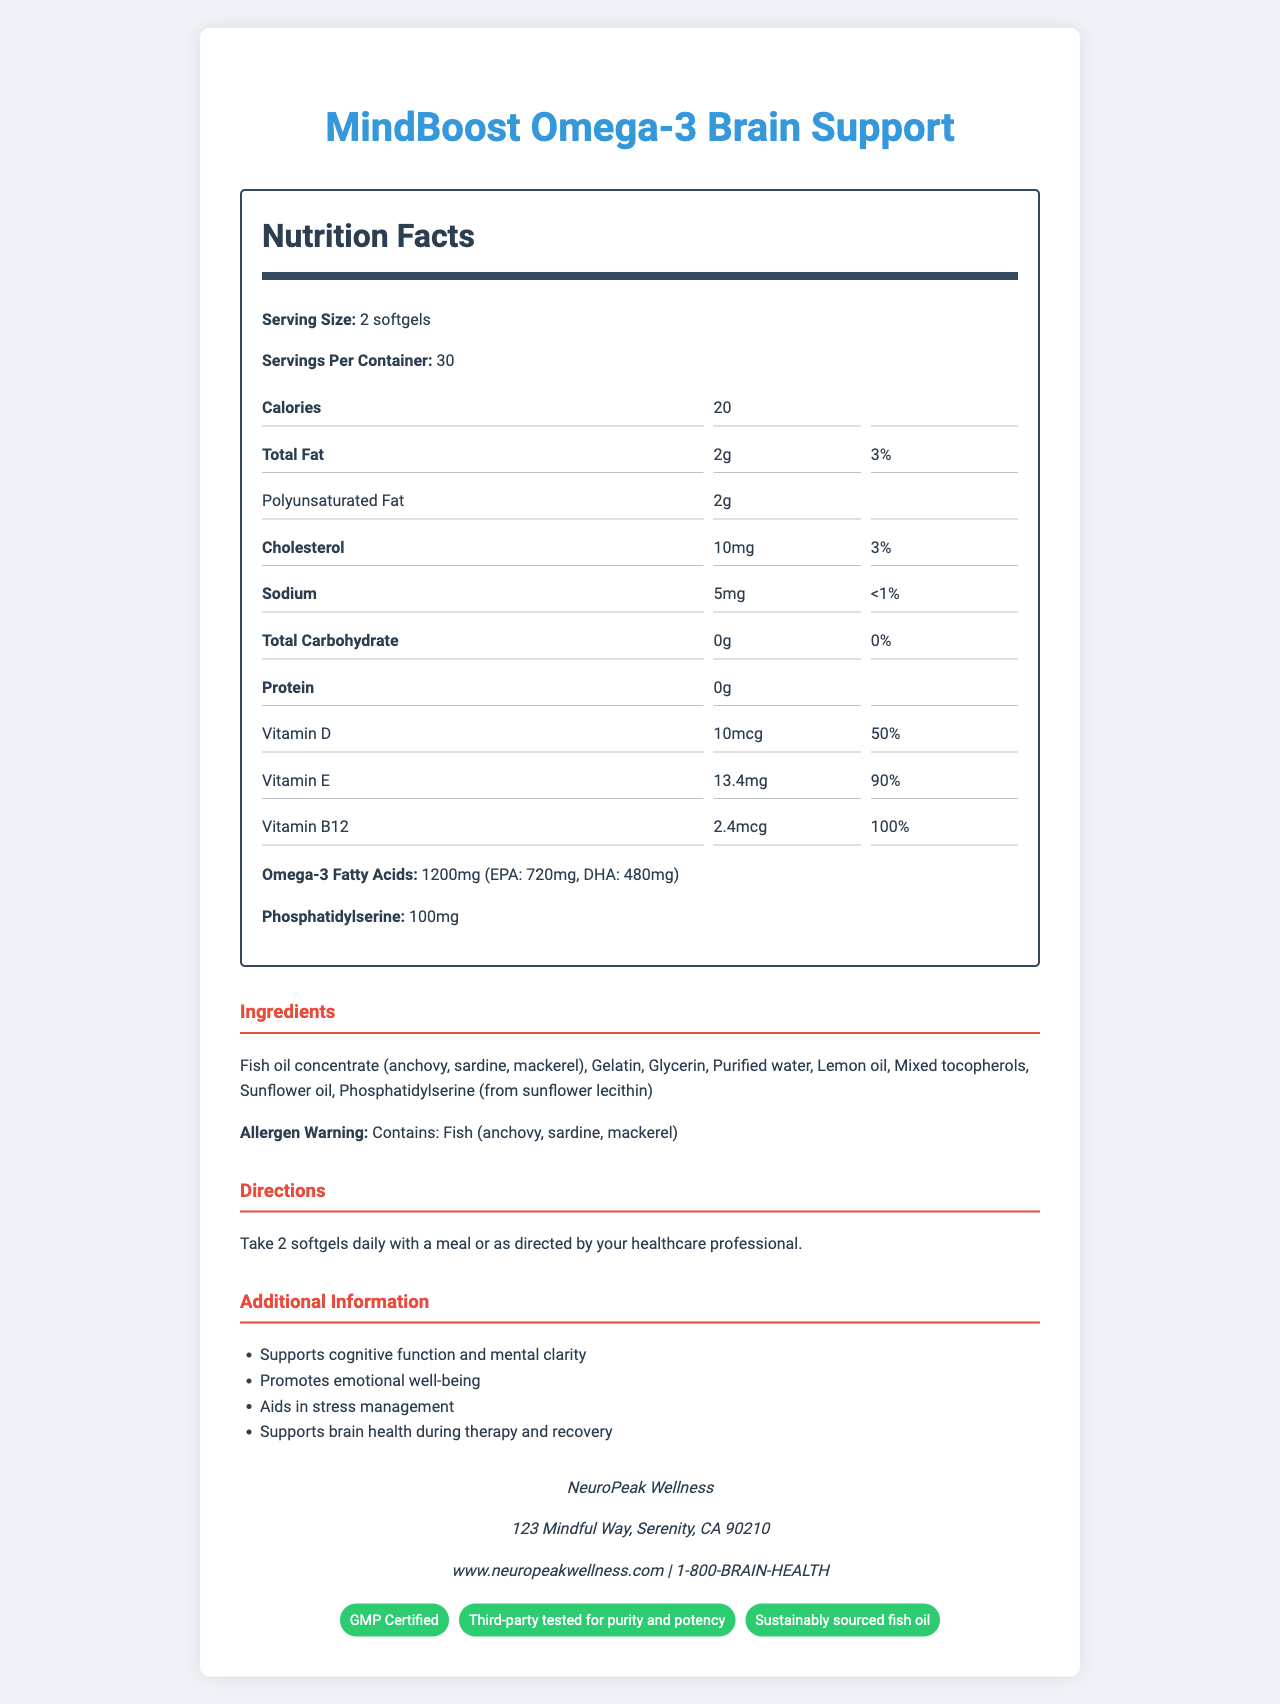what is the serving size? The serving size is mentioned at the top of the nutrition label as "Serving Size: 2 softgels".
Answer: 2 softgels how many servings are in a container? The number of servings per container is listed as "Servings Per Container: 30".
Answer: 30 what is the amount of Vitamin B12 per serving? The nutrition label shows "Vitamin B12: 2.4mcg" under the nutrient section.
Answer: 2.4mcg what is the daily value percentage of Vitamin D? The document states "Vitamin D: 10mcg, 50%" indicating the daily value percentage.
Answer: 50% what allergens are contained in this supplement? The allergen warning section mentions "Contains: Fish (anchovy, sardine, mackerel)".
Answer: Fish (anchovy, sardine, mackerel) what is the total amount of Omega-3 fatty acids per serving? The Omega-3 Fatty Acids section indicates the total amount is "1200mg".
Answer: 1200mg what is the primary source of fish oil used in the product? A. Salmon B. Anchovy, Sardine, Mackerel C. Cod liver The ingredients list specifies "Fish oil concentrate (anchovy, sardine, mackerel)".
Answer: B. Anchovy, Sardine, Mackerel how many milligrams of phosphatidylserine are included per serving? The amount of phosphatidylserine listed is "100mg".
Answer: 100mg how many certifications does the product have? A. One B. Two C. Three The document mentions the product has three certifications: "GMP Certified", "Third-party tested for purity and potency", "Sustainably sourced fish oil".
Answer: C. Three is this supplement recommended to be taken with a meal? The directions specify "Take 2 softgels daily with a meal or as directed by your healthcare professional."
Answer: Yes what is the total fat content per serving? The total fat content is listed as "Total Fat: 2g".
Answer: 2g what is one of the claimed benefits of this supplement? One of the additional information points is "Supports cognitive function and mental clarity".
Answer: Supports cognitive function and mental clarity describe the main purpose of this document The main purpose is to inform consumers about the nutrient content, ingredients, and benefits of the MindBoost Omega-3 supplement.
Answer: The document is a nutrition facts label for the "MindBoost Omega-3 Brain Support" supplement, detailing its serving size, nutrients, ingredients, directions for use, and additional benefits. It includes details about the nutrients provided per serving, the source of ingredients, and the manufacturer's information. what is the total carbohydrate content per serving? The nutrition label indicates "Total Carbohydrate: 0g".
Answer: 0g where is the manufacturer's address located? The manufacturer's address mentioned is "123 Mindful Way, Serenity, CA 90210".
Answer: 123 Mindful Way, Serenity, CA 90210 how much EPA is included in the Omega-3 supplement? The document indicates that EPA content in the Omega-3 supplement is "720mg".
Answer: 720mg which vitamin has the highest daily value percentage in this supplement? The document lists Vitamin B12 with a daily value of "100%", which is the highest among the listed vitamins.
Answer: Vitamin B12 is there any cholesterol in this product? A. Yes, 10mg B. No, 0mg C. Yes, 50mg The nutrients section lists "Cholesterol: 10mg".
Answer: A. Yes, 10mg what is the phone number for customer support? The manufacturer's information includes the phone number "1-800-BRAIN-HEALTH".
Answer: 1-800-BRAIN-HEALTH what percentage of the daily value of total fat does two softgels provide? The nutrition facts indicate "Total Fat: 3%" for a serving size of two softgels.
Answer: 3% how much protein is in each serving? The protein content per serving is mentioned as "0g".
Answer: 0g did the document mention the country where the product is manufactured? The document provides the manufacturer's address but does not specify the country of manufacture.
Answer: Not enough information 